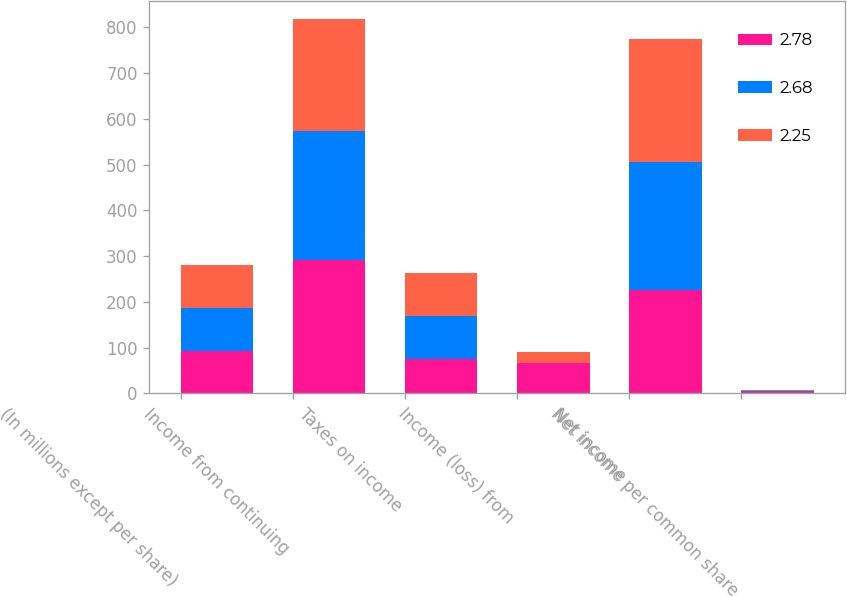<chart> <loc_0><loc_0><loc_500><loc_500><stacked_bar_chart><ecel><fcel>(In millions except per share)<fcel>Income from continuing<fcel>Taxes on income<fcel>Income (loss) from<fcel>Net income<fcel>Net income per common share<nl><fcel>2.78<fcel>93.4<fcel>291.8<fcel>75<fcel>65.4<fcel>226.4<fcel>2.25<nl><fcel>2.68<fcel>93.4<fcel>281<fcel>94.3<fcel>1.3<fcel>279.7<fcel>2.78<nl><fcel>2.25<fcel>93.4<fcel>245.1<fcel>93.4<fcel>22.8<fcel>267.9<fcel>2.68<nl></chart> 